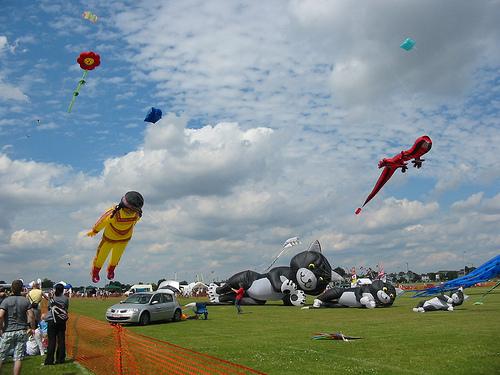How many kites are in the picture?
Keep it brief. 9. What is next to the park?
Write a very short answer. Kites. Are they at a balloon festival?
Answer briefly. Yes. Where was this picture taken?
Give a very brief answer. Outside. What causes the balloons to fly?
Be succinct. Wind. What is lifting up the kites?
Quick response, please. Wind. Are the inflatable cats flying?
Keep it brief. No. Is the sky cloudy?
Short answer required. Yes. 